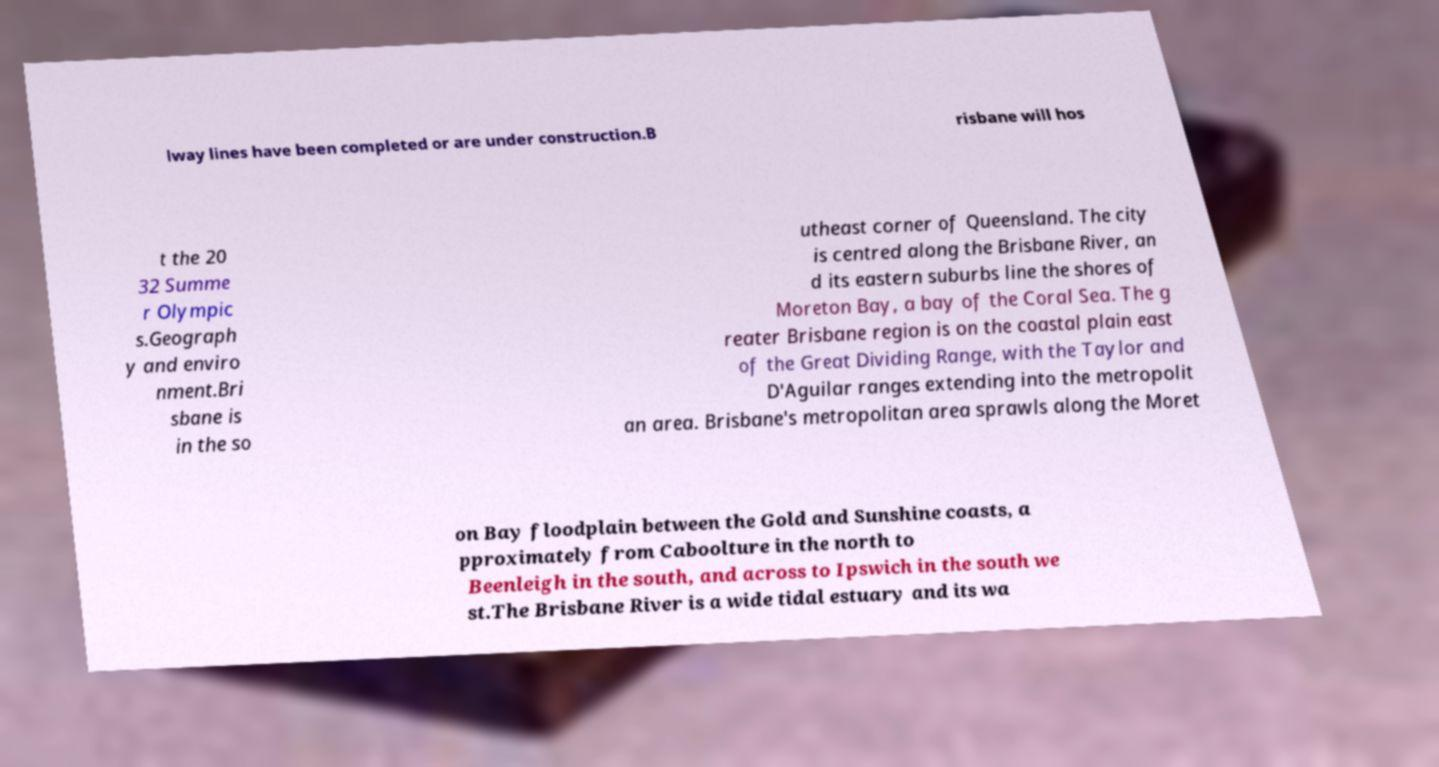Can you accurately transcribe the text from the provided image for me? lway lines have been completed or are under construction.B risbane will hos t the 20 32 Summe r Olympic s.Geograph y and enviro nment.Bri sbane is in the so utheast corner of Queensland. The city is centred along the Brisbane River, an d its eastern suburbs line the shores of Moreton Bay, a bay of the Coral Sea. The g reater Brisbane region is on the coastal plain east of the Great Dividing Range, with the Taylor and D'Aguilar ranges extending into the metropolit an area. Brisbane's metropolitan area sprawls along the Moret on Bay floodplain between the Gold and Sunshine coasts, a pproximately from Caboolture in the north to Beenleigh in the south, and across to Ipswich in the south we st.The Brisbane River is a wide tidal estuary and its wa 